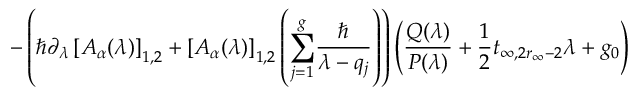<formula> <loc_0><loc_0><loc_500><loc_500>- \left ( \hbar { \partial } _ { \lambda } \left [ A _ { \alpha } ( \lambda ) \right ] _ { 1 , 2 } + \left [ A _ { \alpha } ( \lambda ) \right ] _ { 1 , 2 } \left ( \underset { j = 1 } { \overset { g } { \sum } } \frac { } { \lambda - q _ { j } } \right ) \right ) \left ( \frac { Q ( \lambda ) } { P ( \lambda ) } + \frac { 1 } { 2 } t _ { \infty , 2 r _ { \infty } - 2 } \lambda + g _ { 0 } \right )</formula> 